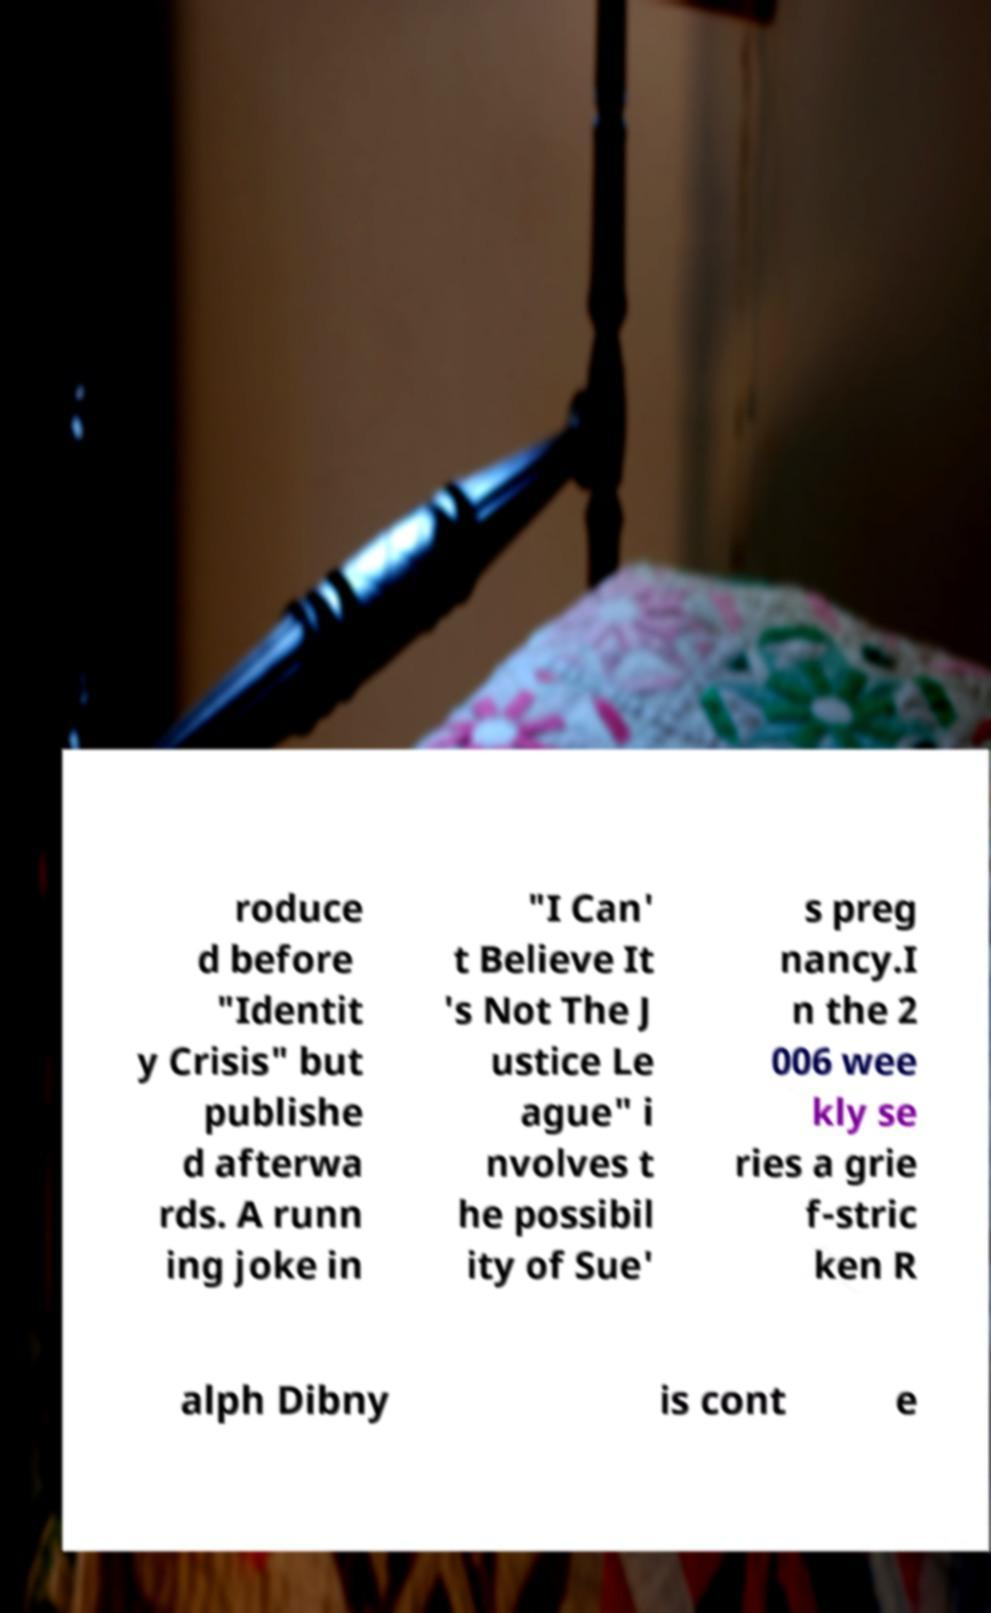What messages or text are displayed in this image? I need them in a readable, typed format. roduce d before "Identit y Crisis" but publishe d afterwa rds. A runn ing joke in "I Can' t Believe It 's Not The J ustice Le ague" i nvolves t he possibil ity of Sue' s preg nancy.I n the 2 006 wee kly se ries a grie f-stric ken R alph Dibny is cont e 